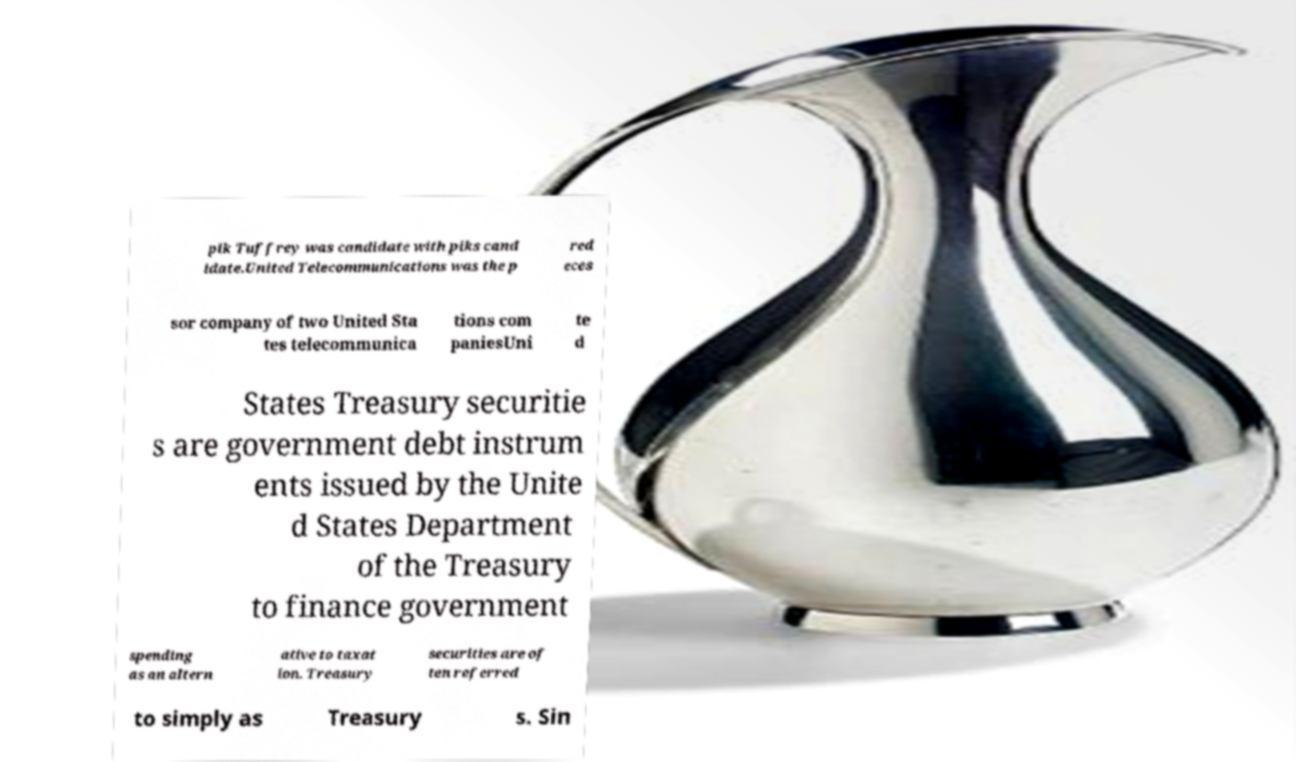Please read and relay the text visible in this image. What does it say? pik Tuffrey was candidate with piks cand idate.United Telecommunications was the p red eces sor company of two United Sta tes telecommunica tions com paniesUni te d States Treasury securitie s are government debt instrum ents issued by the Unite d States Department of the Treasury to finance government spending as an altern ative to taxat ion. Treasury securities are of ten referred to simply as Treasury s. Sin 